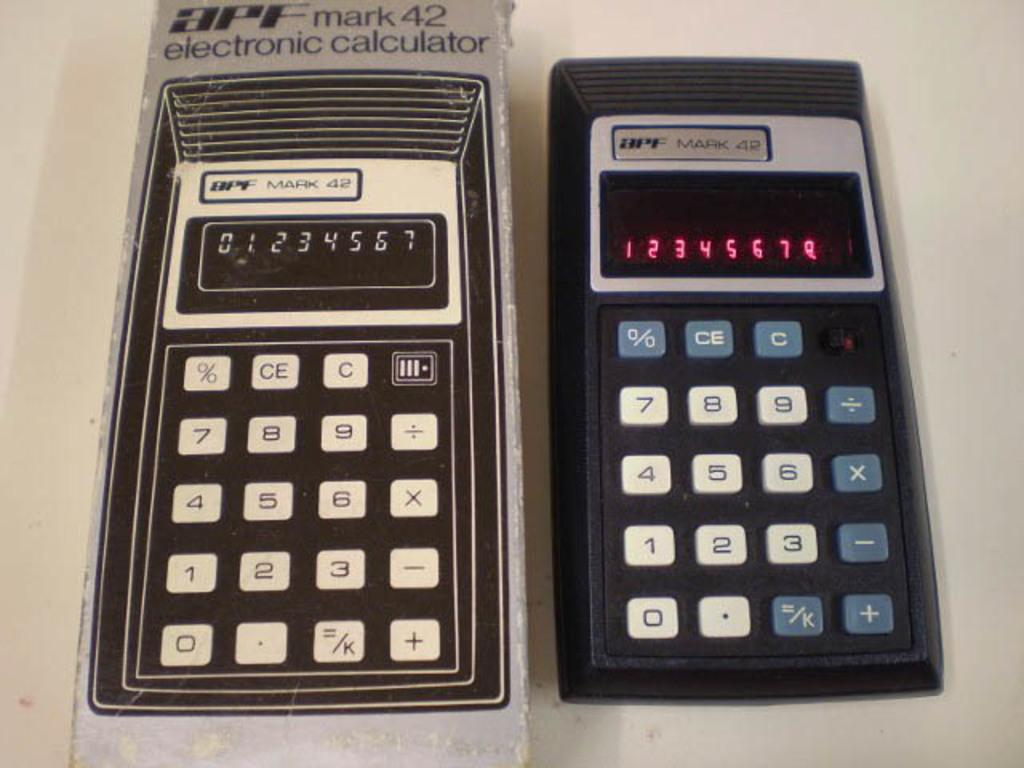<image>
Write a terse but informative summary of the picture. A box and APF Mark 42 calculator displayed 